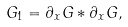Convert formula to latex. <formula><loc_0><loc_0><loc_500><loc_500>G _ { 1 } = \partial _ { x } G * \partial _ { x } G ,</formula> 